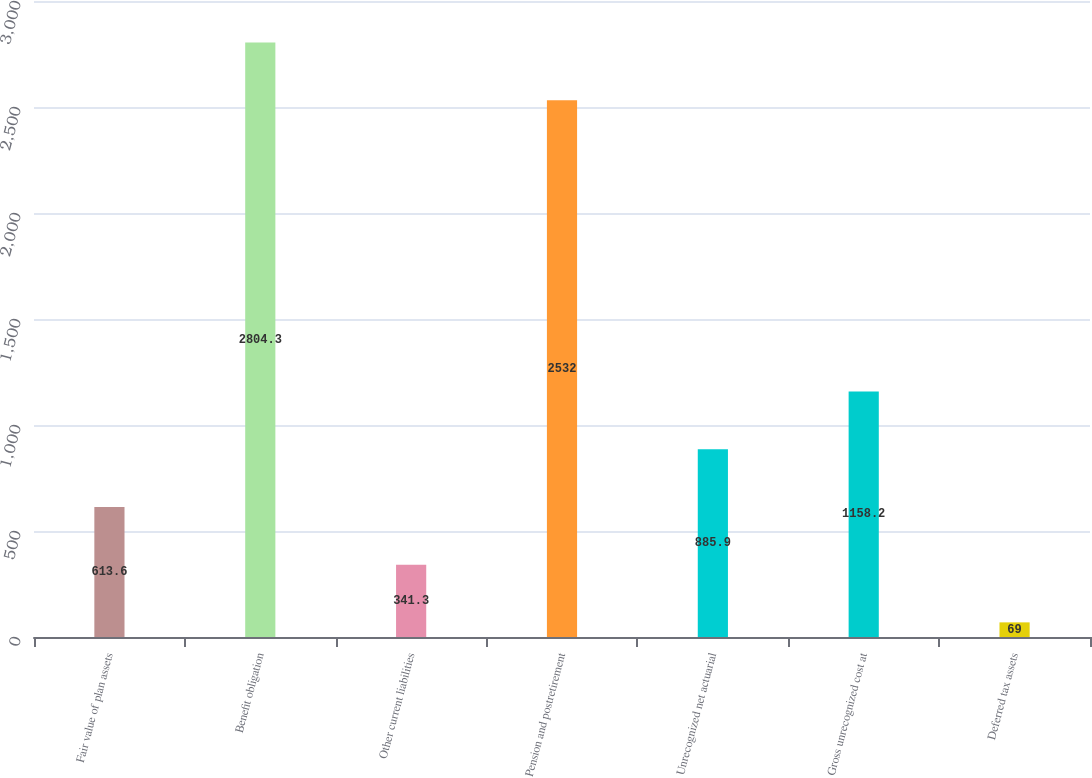<chart> <loc_0><loc_0><loc_500><loc_500><bar_chart><fcel>Fair value of plan assets<fcel>Benefit obligation<fcel>Other current liabilities<fcel>Pension and postretirement<fcel>Unrecognized net actuarial<fcel>Gross unrecognized cost at<fcel>Deferred tax assets<nl><fcel>613.6<fcel>2804.3<fcel>341.3<fcel>2532<fcel>885.9<fcel>1158.2<fcel>69<nl></chart> 